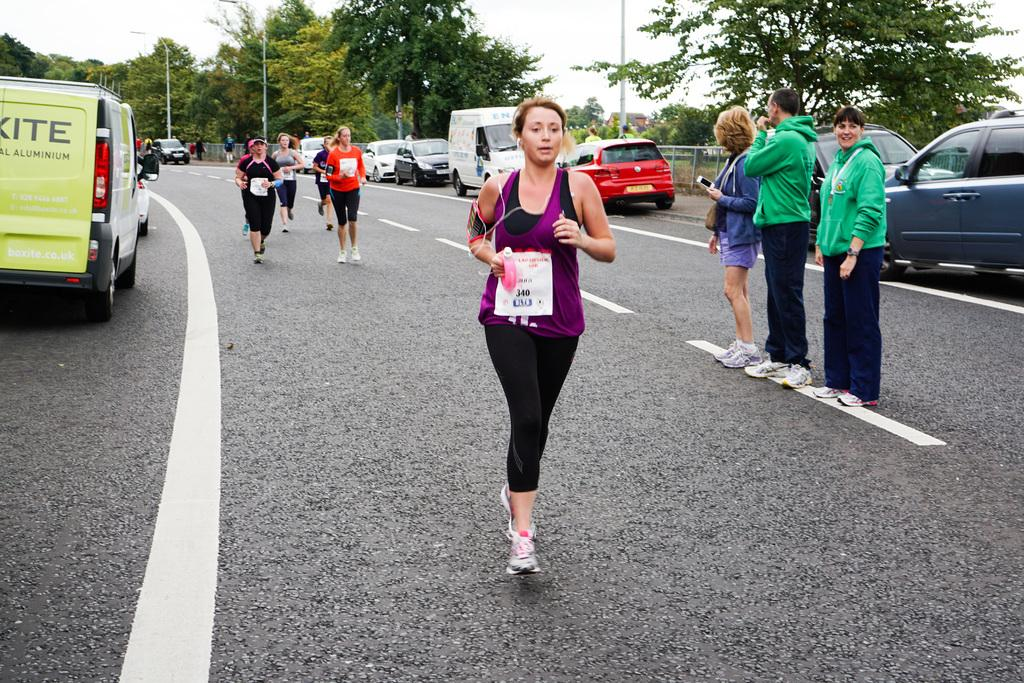<image>
Give a short and clear explanation of the subsequent image. a lady that has 340 written on a white paper 